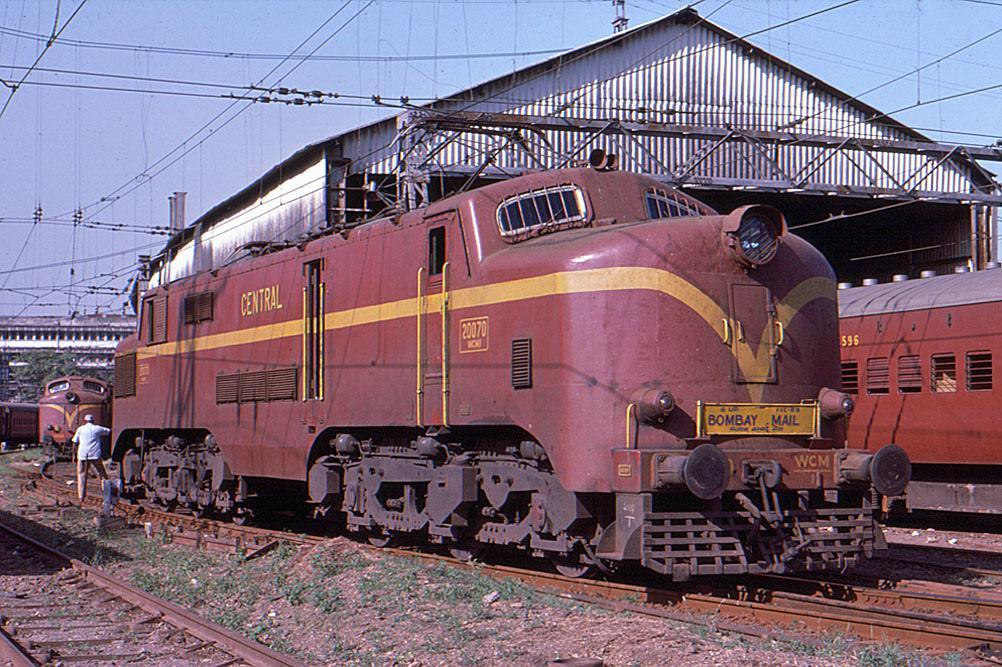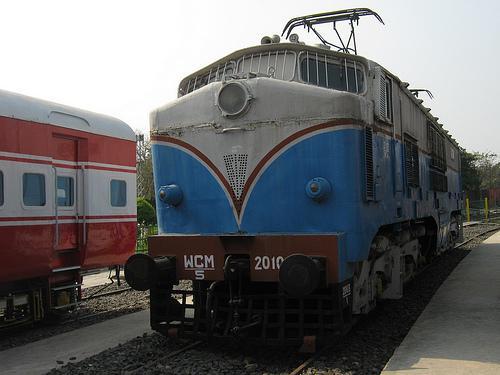The first image is the image on the left, the second image is the image on the right. Evaluate the accuracy of this statement regarding the images: "One train has a blue body and a white top that extends in an upside-down V-shape on the front of the train.". Is it true? Answer yes or no. Yes. 